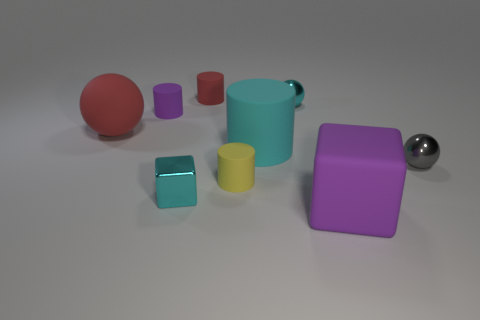The tiny metal thing that is the same color as the small block is what shape?
Keep it short and to the point. Sphere. There is a gray metallic ball; is it the same size as the purple object that is right of the tiny purple rubber cylinder?
Your answer should be very brief. No. There is a purple thing that is to the right of the tiny cylinder behind the purple matte object behind the red rubber sphere; how big is it?
Your response must be concise. Large. What is the size of the purple rubber object in front of the cyan cube?
Offer a terse response. Large. What is the shape of the yellow object that is made of the same material as the red sphere?
Your answer should be very brief. Cylinder. Do the tiny ball in front of the large red sphere and the cyan cylinder have the same material?
Give a very brief answer. No. How many other objects are the same material as the gray ball?
Provide a succinct answer. 2. How many objects are small things that are behind the small gray sphere or cyan metal objects in front of the small gray metallic sphere?
Your answer should be compact. 4. There is a tiny metallic thing left of the small yellow rubber object; is its shape the same as the cyan shiny thing that is behind the gray ball?
Offer a terse response. No. There is a red thing that is the same size as the yellow thing; what shape is it?
Offer a very short reply. Cylinder. 